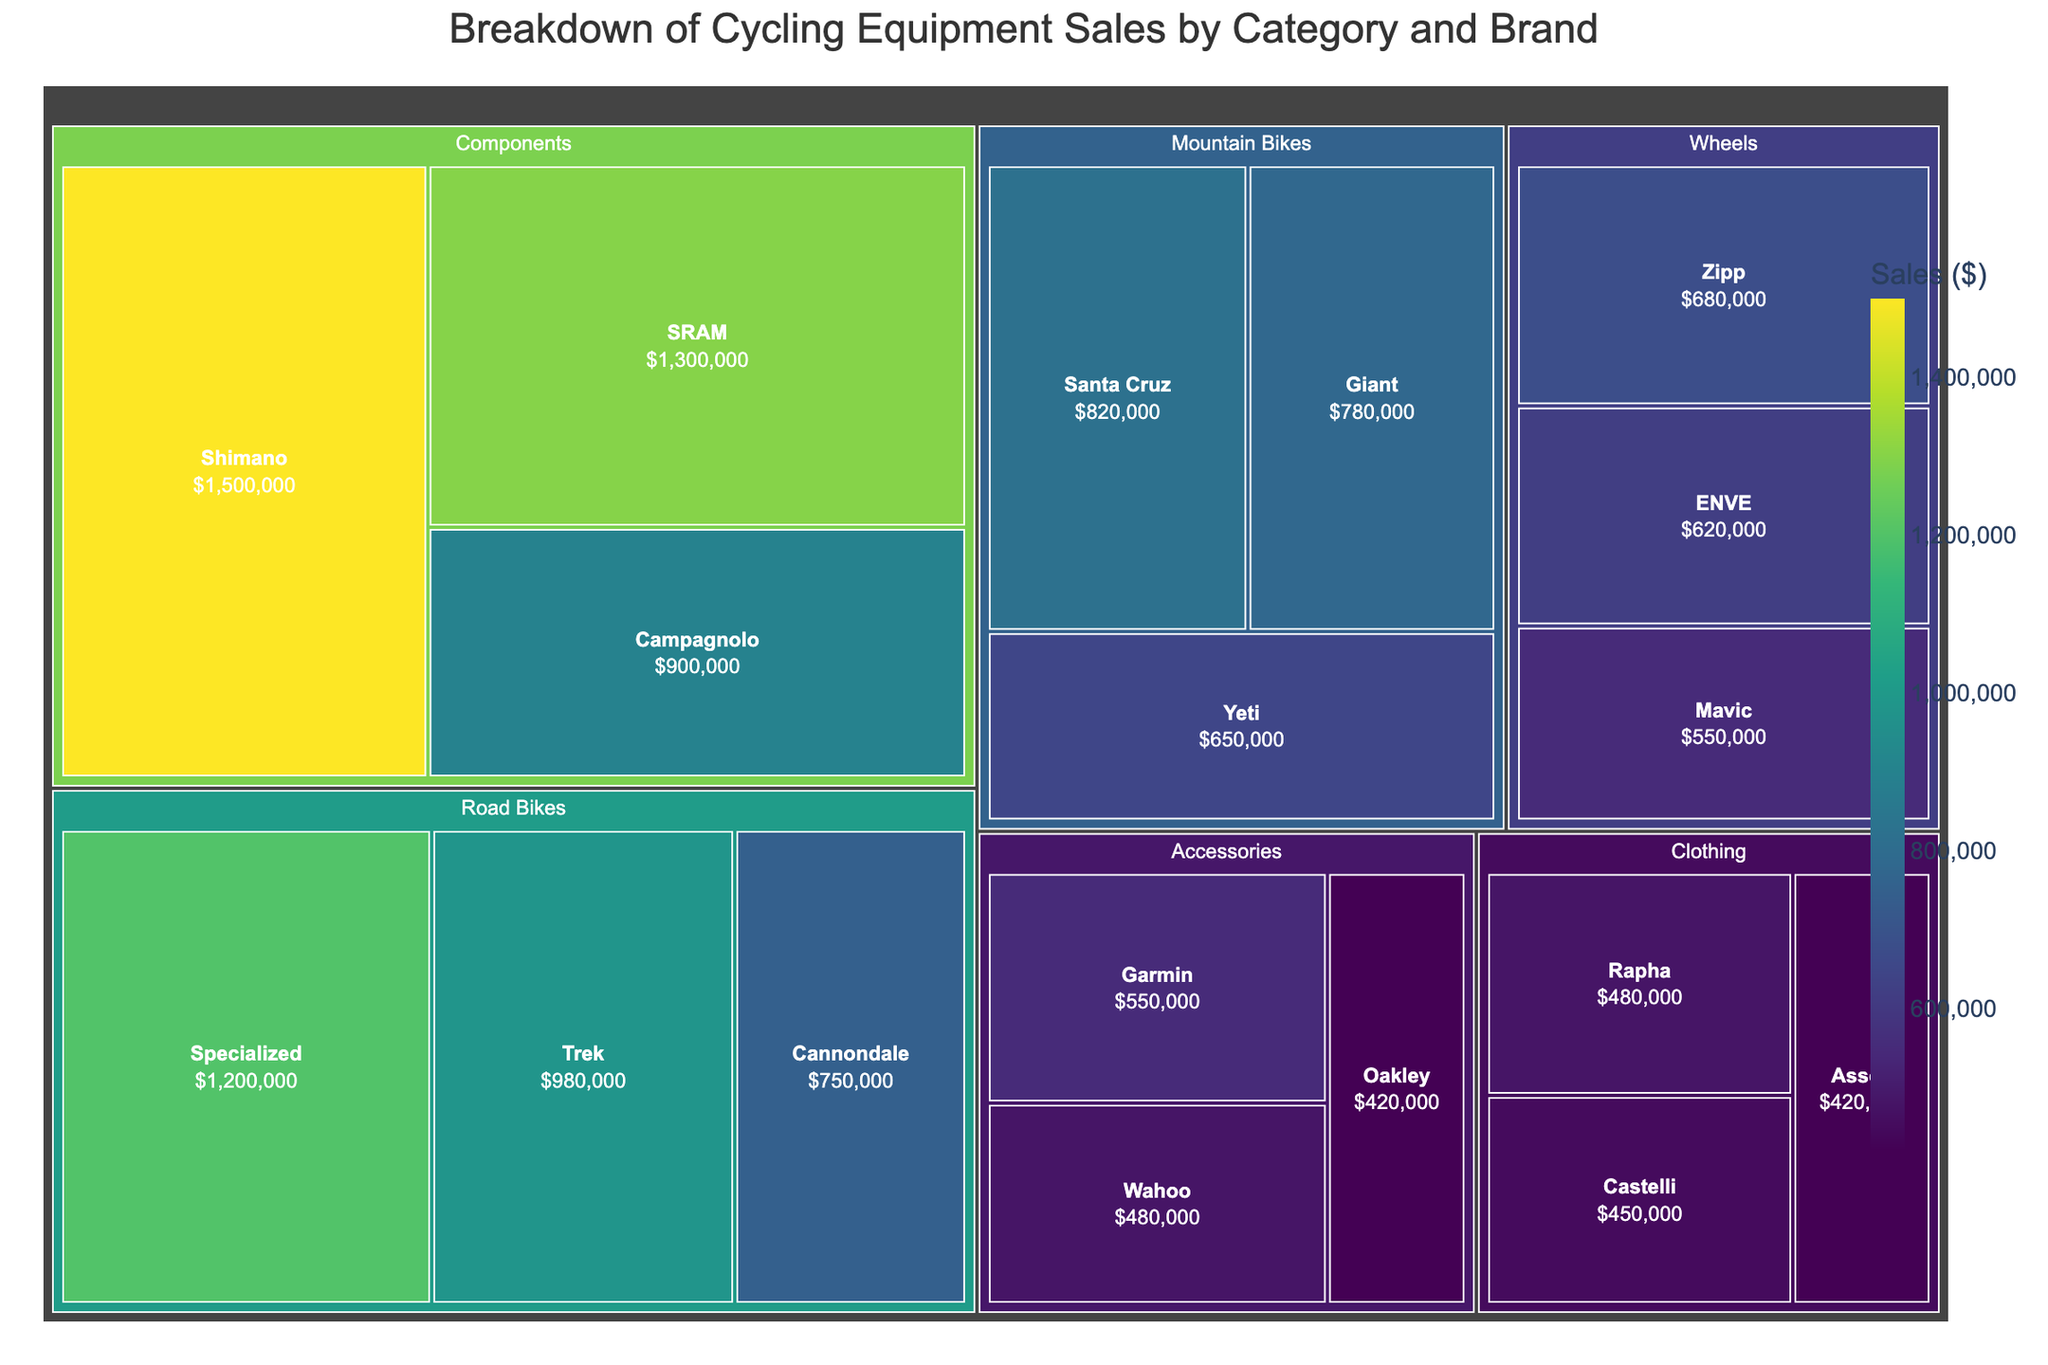What is the title of the treemap? The title is usually found at the top of the treemap and describes the content of the figure.
Answer: Breakdown of Cycling Equipment Sales by Category and Brand Which brand has the highest sales in the Components category? Locate the Components category in the treemap and identify the brand with the largest area, which represents the highest sales.
Answer: Shimano How much are the total sales for the Wheels category? Find the sales values for each brand within the Wheels category and sum them up (680,000 + 620,000 + 550,000). The sum is 1,850,000.
Answer: $1,850,000 Which category has the lowest total sales, and what are the sales? Compare the total sales of each category by summing the sales figures for the brands within each category. The category with the smallest sum has the lowest total sales. Accessories: 550,000 + 480,000 + 420,000 = 1,450,000 Clothing: 480,000 + 450,000 + 420,000 = 1,350,000 Clothing has the lowest total sales.
Answer: Clothing, $1,350,000 How do the sales of Specialized Road Bikes compare to Cannondale Road Bikes? Identify the sales figures for both Specialized and Cannondale within the Road Bikes category and compare them directly. Specialized: 1,200,000; Cannondale: 750,000. Specialized has higher sales.
Answer: Specialized has higher sales than Cannondale What percentage of total Road Bikes sales do Trek contribute? Find the total sales for Road Bikes by summing the sales of all brands in this category (1,200,000 + 980,000 + 750,000 = 2,930,000). Then, divide Trek's sales by the total Road Bikes sales and multiply by 100 to get the percentage: (980,000 / 2,930,000) * 100 ≈ 33.45%.
Answer: Approximately 33.45% If Shimano and SRAM sales are combined, what is their total in the Components category, and how does it compare to the total sales of Road Bikes? Sum the sales of Shimano and SRAM (1,500,000 + 1,300,000 = 2,800,000). Compare this figure with the total sales of Road Bikes (2,930,000). Shimano and SRAM combined sales are slightly less than Road Bikes sales.
Answer: $2,800,000, less than Road Bikes sales Which brand in the Accessories category has the least sales, and how much is it? Identify the brand within the Accessories category that has the smallest area (representing the least sales). Oakley: 420,000 is the smallest.
Answer: Oakley, $420,000 What are the average sales of the brands in the Mountain Bikes category? Find the sales figures for all brands in the Mountain Bikes category (820,000 + 780,000 + 650,000). Sum these values and divide by the number of brands (3). (820,000 + 780,000 + 650,000) / 3 = 750,000.
Answer: $750,000 